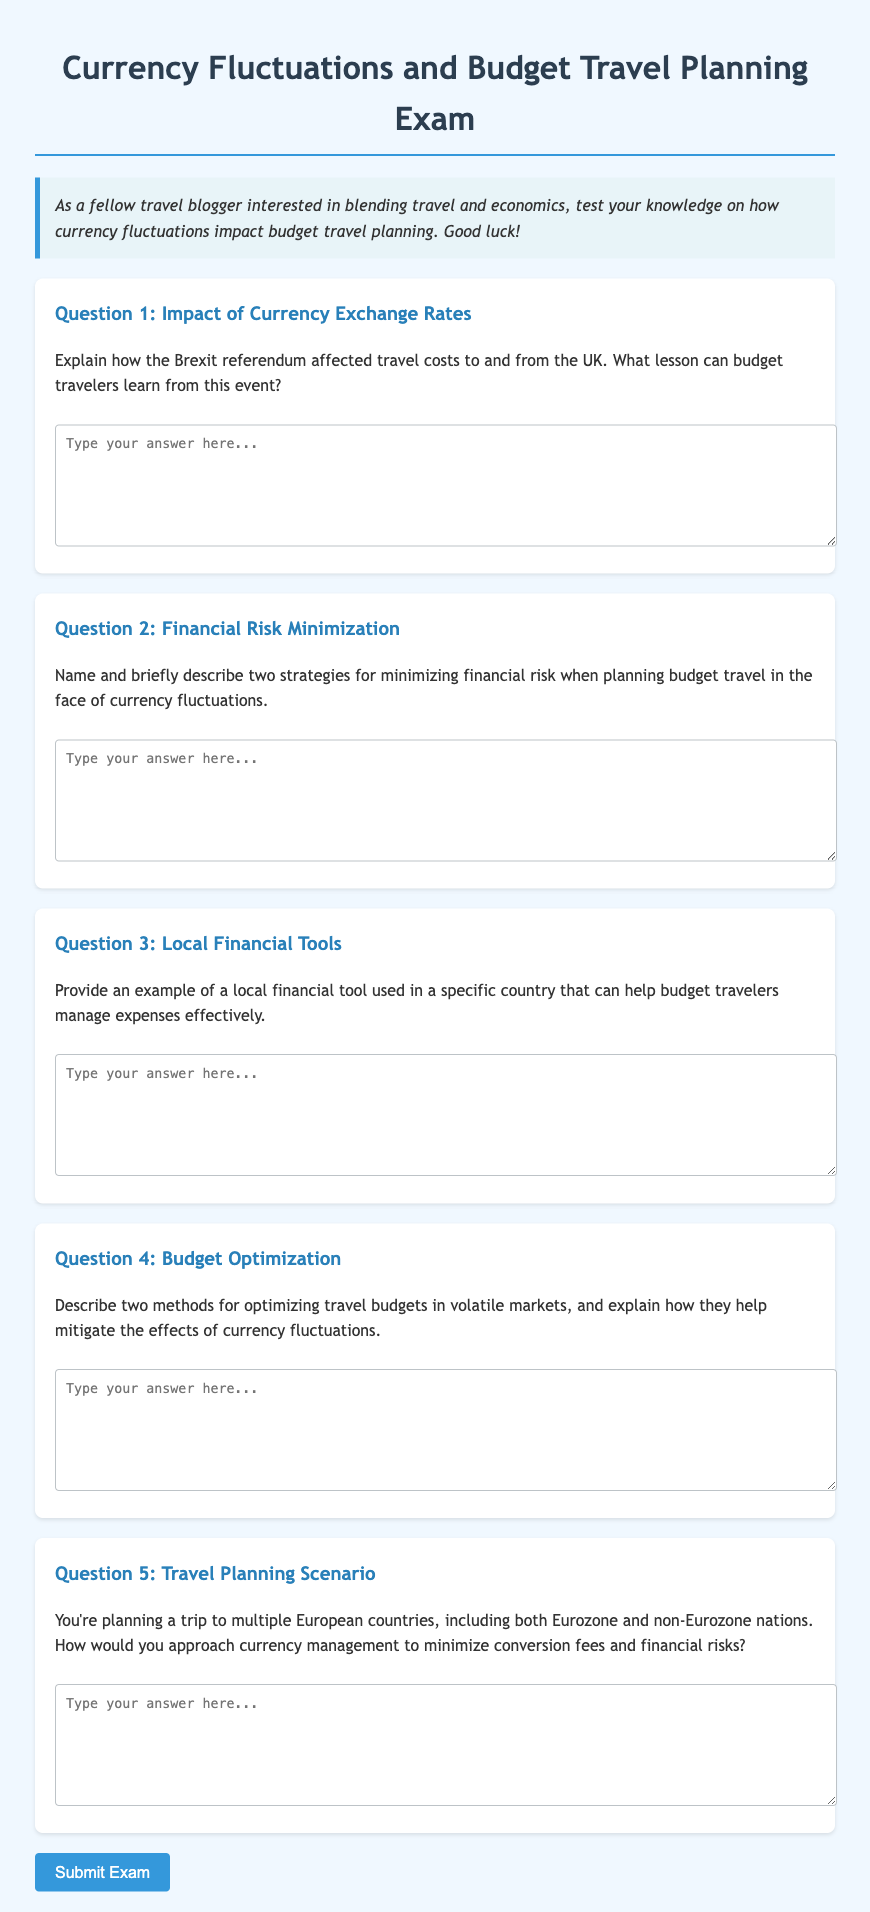What is the title of the exam? The title of the exam is stated at the top of the document.
Answer: Currency Fluctuations and Budget Travel Planning Exam How many questions are included in the exam? The document lists five distinct questions for the exam.
Answer: 5 What is one specific event mentioned that affected travel costs to and from the UK? The first question refers to a historical event that impacted exchange rates and costs.
Answer: Brexit referendum Name one strategy for minimizing financial risk in budget travel. The second question asks for strategies that deal with financial risk in travel planning.
Answer: Specific strategy is not provided, but it asks for two What type of example is requested in Question 3? The third question specifies the type of financial tool that budget travelers can use in a local context.
Answer: Local financial tool Which market conditions are being addressed in relation to budgeting? The fourth question refers to specific economic situations that may vary and impact travel budgets.
Answer: Volatile markets In what scenario are travelers advised to manage currency? The fifth question describes a situation where travelers may need to consider multiple currencies.
Answer: Trip to multiple European countries What is the purpose of the “Submit Exam” button? The button at the bottom of the document serves a clear action related to the exam process.
Answer: To submit answers 